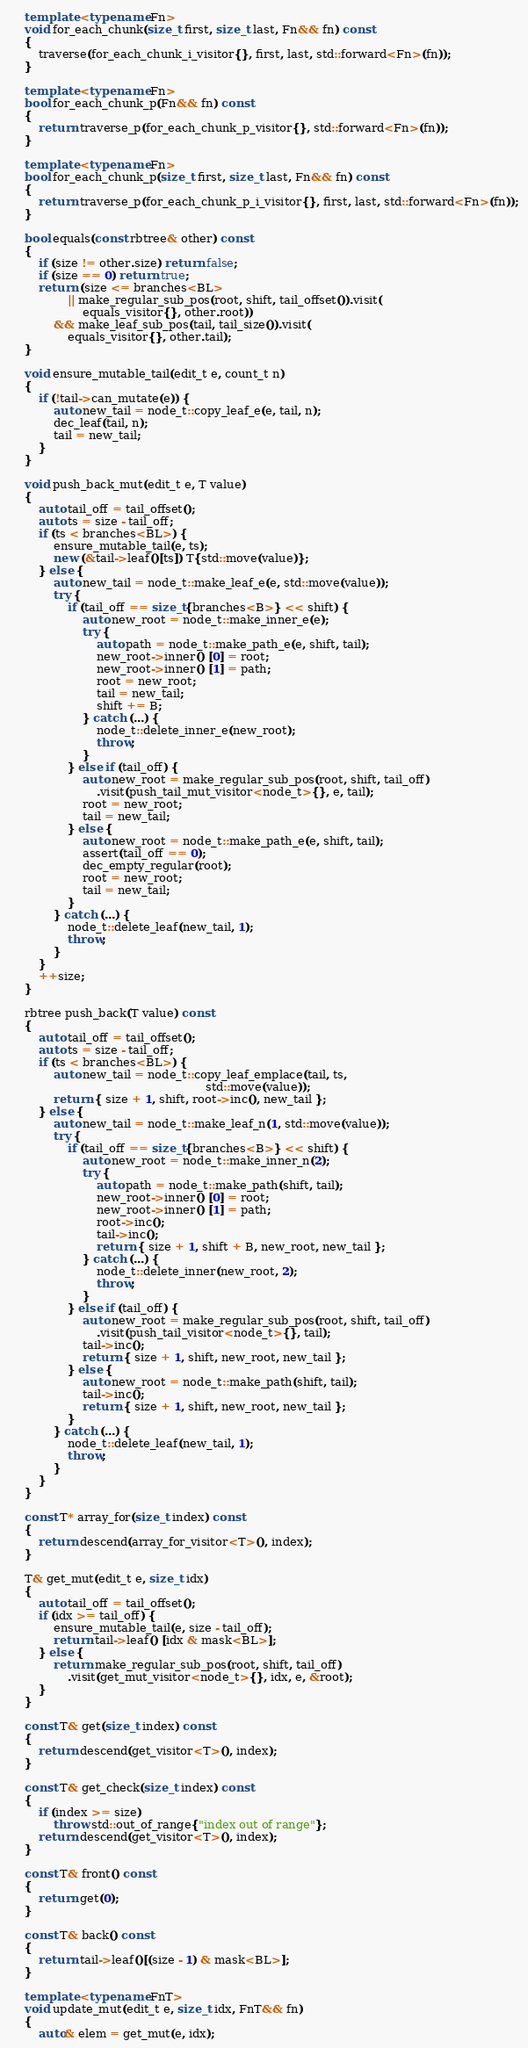<code> <loc_0><loc_0><loc_500><loc_500><_C++_>    template <typename Fn>
    void for_each_chunk(size_t first, size_t last, Fn&& fn) const
    {
        traverse(for_each_chunk_i_visitor{}, first, last, std::forward<Fn>(fn));
    }

    template <typename Fn>
    bool for_each_chunk_p(Fn&& fn) const
    {
        return traverse_p(for_each_chunk_p_visitor{}, std::forward<Fn>(fn));
    }

    template <typename Fn>
    bool for_each_chunk_p(size_t first, size_t last, Fn&& fn) const
    {
        return traverse_p(for_each_chunk_p_i_visitor{}, first, last, std::forward<Fn>(fn));
    }

    bool equals(const rbtree& other) const
    {
        if (size != other.size) return false;
        if (size == 0) return true;
        return (size <= branches<BL>
                || make_regular_sub_pos(root, shift, tail_offset()).visit(
                    equals_visitor{}, other.root))
            && make_leaf_sub_pos(tail, tail_size()).visit(
                equals_visitor{}, other.tail);
    }

    void ensure_mutable_tail(edit_t e, count_t n)
    {
        if (!tail->can_mutate(e)) {
            auto new_tail = node_t::copy_leaf_e(e, tail, n);
            dec_leaf(tail, n);
            tail = new_tail;
        }
    }

    void push_back_mut(edit_t e, T value)
    {
        auto tail_off = tail_offset();
        auto ts = size - tail_off;
        if (ts < branches<BL>) {
            ensure_mutable_tail(e, ts);
            new (&tail->leaf()[ts]) T{std::move(value)};
        } else {
            auto new_tail = node_t::make_leaf_e(e, std::move(value));
            try {
                if (tail_off == size_t{branches<B>} << shift) {
                    auto new_root = node_t::make_inner_e(e);
                    try {
                        auto path = node_t::make_path_e(e, shift, tail);
                        new_root->inner() [0] = root;
                        new_root->inner() [1] = path;
                        root = new_root;
                        tail = new_tail;
                        shift += B;
                    } catch (...) {
                        node_t::delete_inner_e(new_root);
                        throw;
                    }
                } else if (tail_off) {
                    auto new_root = make_regular_sub_pos(root, shift, tail_off)
                        .visit(push_tail_mut_visitor<node_t>{}, e, tail);
                    root = new_root;
                    tail = new_tail;
                } else {
                    auto new_root = node_t::make_path_e(e, shift, tail);
                    assert(tail_off == 0);
                    dec_empty_regular(root);
                    root = new_root;
                    tail = new_tail;
                }
            } catch (...) {
                node_t::delete_leaf(new_tail, 1);
                throw;
            }
        }
        ++size;
    }

    rbtree push_back(T value) const
    {
        auto tail_off = tail_offset();
        auto ts = size - tail_off;
        if (ts < branches<BL>) {
            auto new_tail = node_t::copy_leaf_emplace(tail, ts,
                                                      std::move(value));
            return { size + 1, shift, root->inc(), new_tail };
        } else {
            auto new_tail = node_t::make_leaf_n(1, std::move(value));
            try {
                if (tail_off == size_t{branches<B>} << shift) {
                    auto new_root = node_t::make_inner_n(2);
                    try {
                        auto path = node_t::make_path(shift, tail);
                        new_root->inner() [0] = root;
                        new_root->inner() [1] = path;
                        root->inc();
                        tail->inc();
                        return { size + 1, shift + B, new_root, new_tail };
                    } catch (...) {
                        node_t::delete_inner(new_root, 2);
                        throw;
                    }
                } else if (tail_off) {
                    auto new_root = make_regular_sub_pos(root, shift, tail_off)
                        .visit(push_tail_visitor<node_t>{}, tail);
                    tail->inc();
                    return { size + 1, shift, new_root, new_tail };
                } else {
                    auto new_root = node_t::make_path(shift, tail);
                    tail->inc();
                    return { size + 1, shift, new_root, new_tail };
                }
            } catch (...) {
                node_t::delete_leaf(new_tail, 1);
                throw;
            }
        }
    }

    const T* array_for(size_t index) const
    {
        return descend(array_for_visitor<T>(), index);
    }

    T& get_mut(edit_t e, size_t idx)
    {
        auto tail_off = tail_offset();
        if (idx >= tail_off) {
            ensure_mutable_tail(e, size - tail_off);
            return tail->leaf() [idx & mask<BL>];
        } else {
            return make_regular_sub_pos(root, shift, tail_off)
                .visit(get_mut_visitor<node_t>{}, idx, e, &root);
        }
    }

    const T& get(size_t index) const
    {
        return descend(get_visitor<T>(), index);
    }

    const T& get_check(size_t index) const
    {
        if (index >= size)
            throw std::out_of_range{"index out of range"};
        return descend(get_visitor<T>(), index);
    }

    const T& front() const
    {
        return get(0);
    }

    const T& back() const
    {
        return tail->leaf()[(size - 1) & mask<BL>];
    }

    template <typename FnT>
    void update_mut(edit_t e, size_t idx, FnT&& fn)
    {
        auto& elem = get_mut(e, idx);</code> 